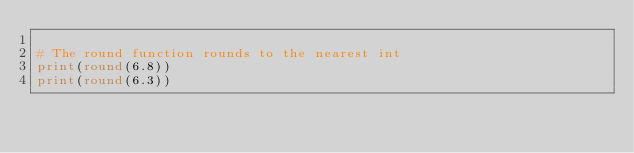<code> <loc_0><loc_0><loc_500><loc_500><_Python_>
# The round function rounds to the nearest int
print(round(6.8))
print(round(6.3))</code> 